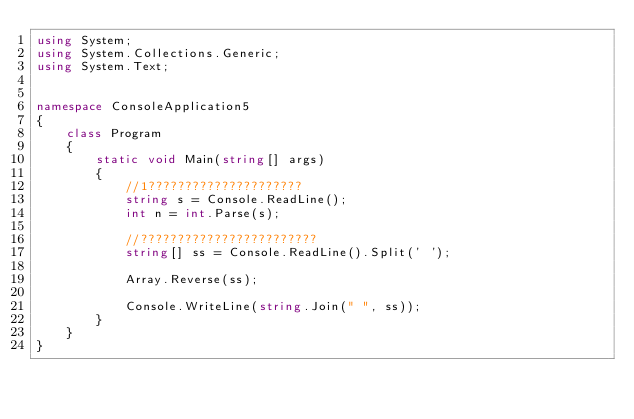<code> <loc_0><loc_0><loc_500><loc_500><_C#_>using System;
using System.Collections.Generic;
using System.Text;


namespace ConsoleApplication5
{
    class Program
    {
        static void Main(string[] args)
        {
            //1?????????????????????
            string s = Console.ReadLine();
            int n = int.Parse(s);

            //????????????????????????
            string[] ss = Console.ReadLine().Split(' ');

            Array.Reverse(ss);

            Console.WriteLine(string.Join(" ", ss));
        }
    }
}</code> 